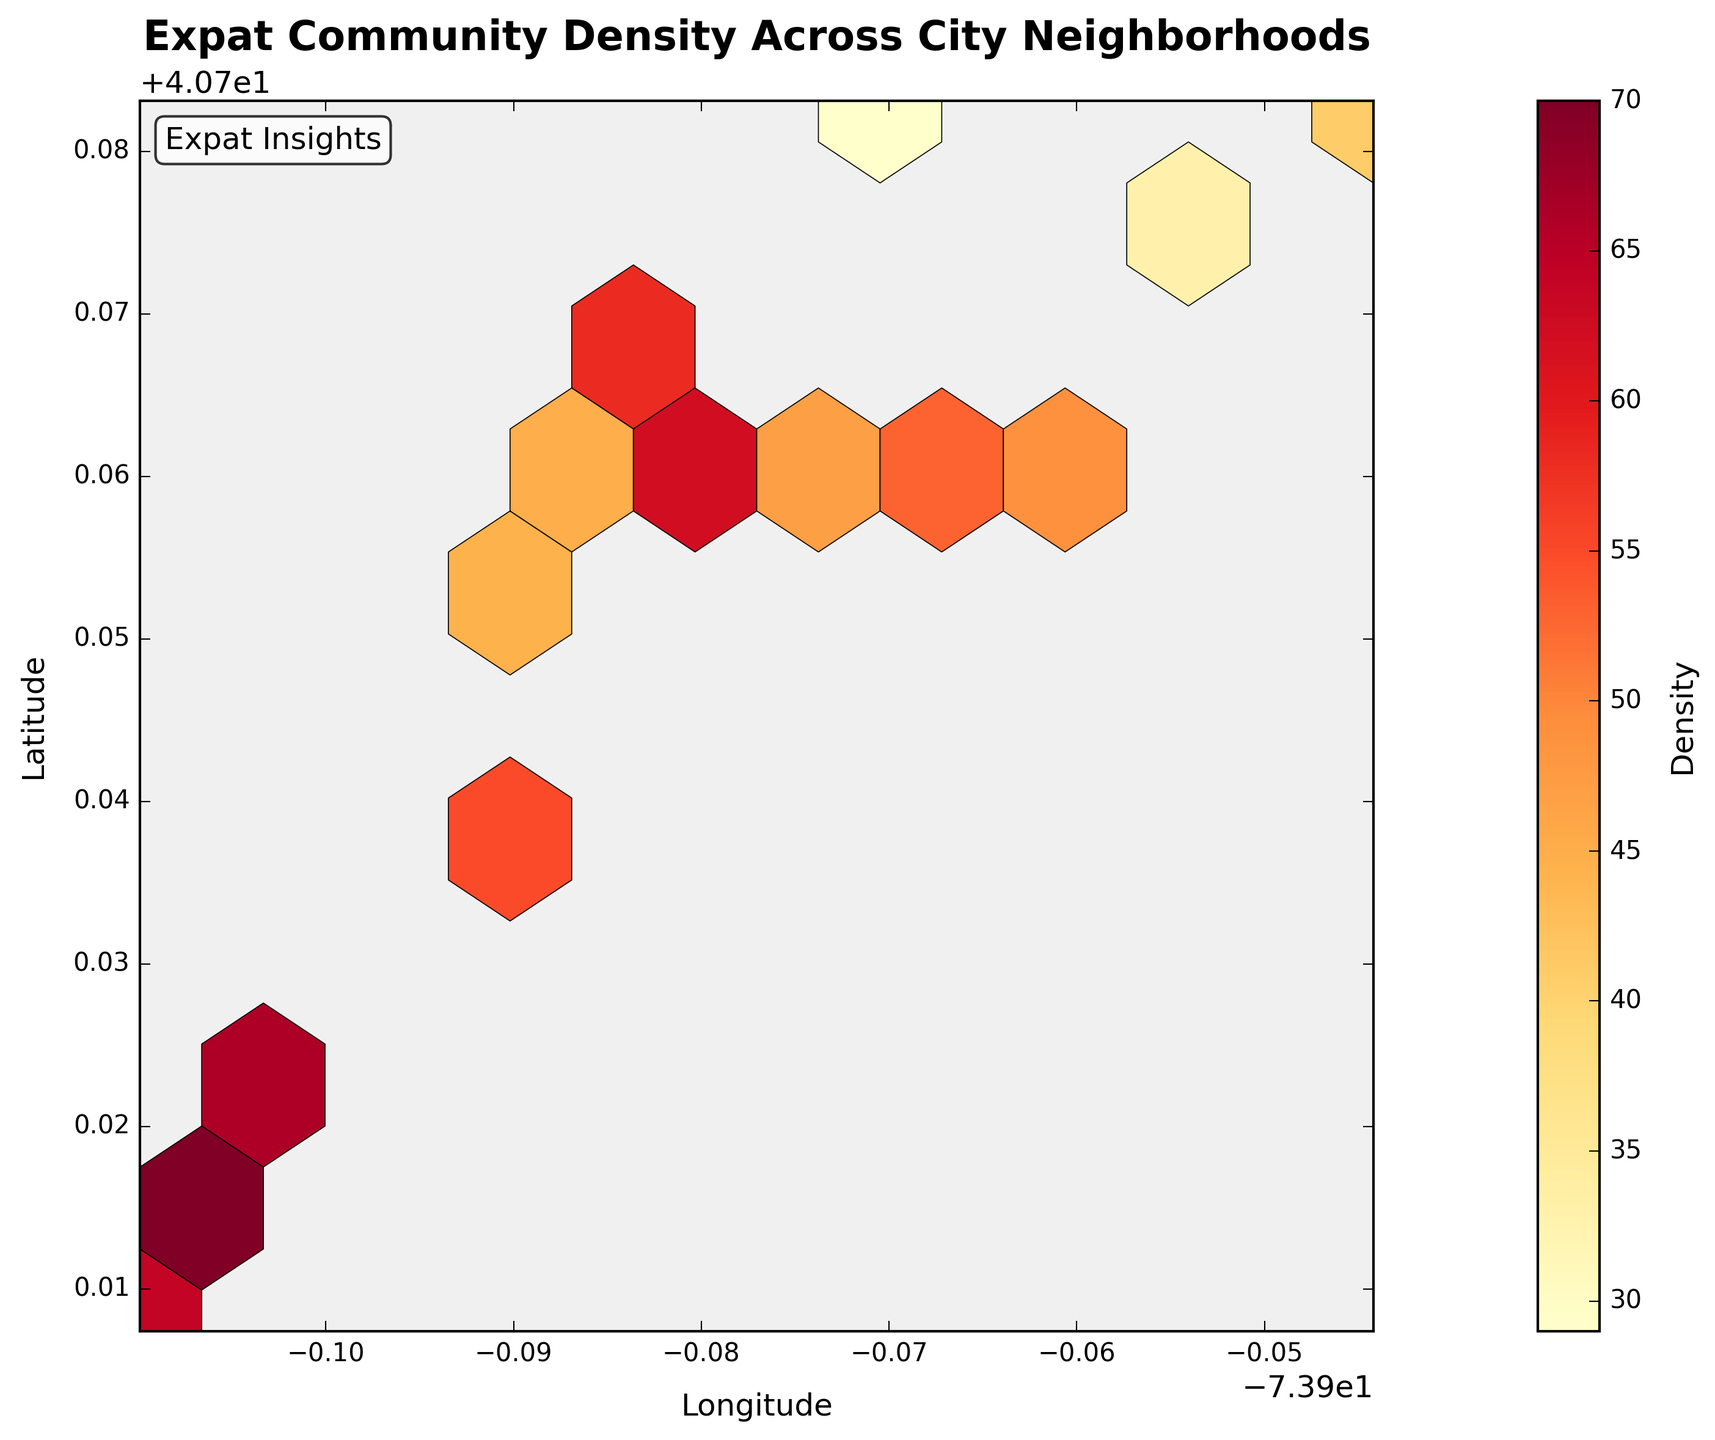What is the title of the figure? The title is located at the top of the plot and usually describes what the plot is about. In this case, the title is "Expat Community Density Across City Neighborhoods".
Answer: Expat Community Density Across City Neighborhoods What do the colors in the hexagons represent? The colors in the hexagons indicate different levels of density, with a color bar on the right side of the figure showing the scale from low to high density.
Answer: Density What are the axes labels of the figure? The labels of the axes can be found beside the respective x-axis and y-axis. Here, the x-axis is labeled "Longitude" and the y-axis is labeled "Latitude".
Answer: Longitude and Latitude Which neighborhood has the highest density of expat communities? To determine the neighborhood with the highest density, look for the darkest hexagon. According to the color bar, the highest density is represented by the darkest color. The hexagon at coordinates approximately (-74.0060, 40.7128) has the highest density value of 70.
Answer: Approx. (-74.0060, 40.7128) Is the density higher in the north or south of the city? By comparing the density colors of hexagons in the northern and southern parts of the plot, we can see that the southern part, towards coordinates around (-74.0060, 40.7128), has darker hexagons, indicating a higher density.
Answer: South Which area has a density of 62? To find an area with a specific density, look at the hexagons that match the color corresponding to 62 on the color bar. The hexagon around the coordinates (-73.9777, 40.7614) has a density of 62.
Answer: Approx. (-73.9777, 40.7614) What is the difference in density between the neighborhoods at (-73.9679, 40.7637) and (-73.9442, 40.7822)? Find the densities of the neighborhoods from the color bar and subtract them. (-73.9679, 40.7637) has a density of 53 and (-73.9442, 40.7822) has a density of 41. The difference is 53 - 41 = 12.
Answer: 12 How many unique density values are there in the figure? Count the different densities noted in the color bar and the hexagons. The unique density values presented are: 29, 33, 38, 41, 45, 47, 49, 51, 53, 55, 58, 62, 64, 66, 70. So, there are 15 unique values.
Answer: 15 Do neighborhoods with similar longitudes but different latitudes have varying densities? Compare hexagons that have similar x-axis coordinates (longitude) but different y-axis coordinates (latitude). For instance, (-73.9712, 40.7831) with a density of 29 and (-73.9738, 40.7648) with a density of 47 have the same longitude but different latitudes and different densities.
Answer: Yes What is the general trend in density as you move from west to east across the city? Look at the progression of colors from left (west) to right (east). The hexagons get lighter in color as you move from west (left) to east (right), indicating a decrease in density.
Answer: Decreasing density 